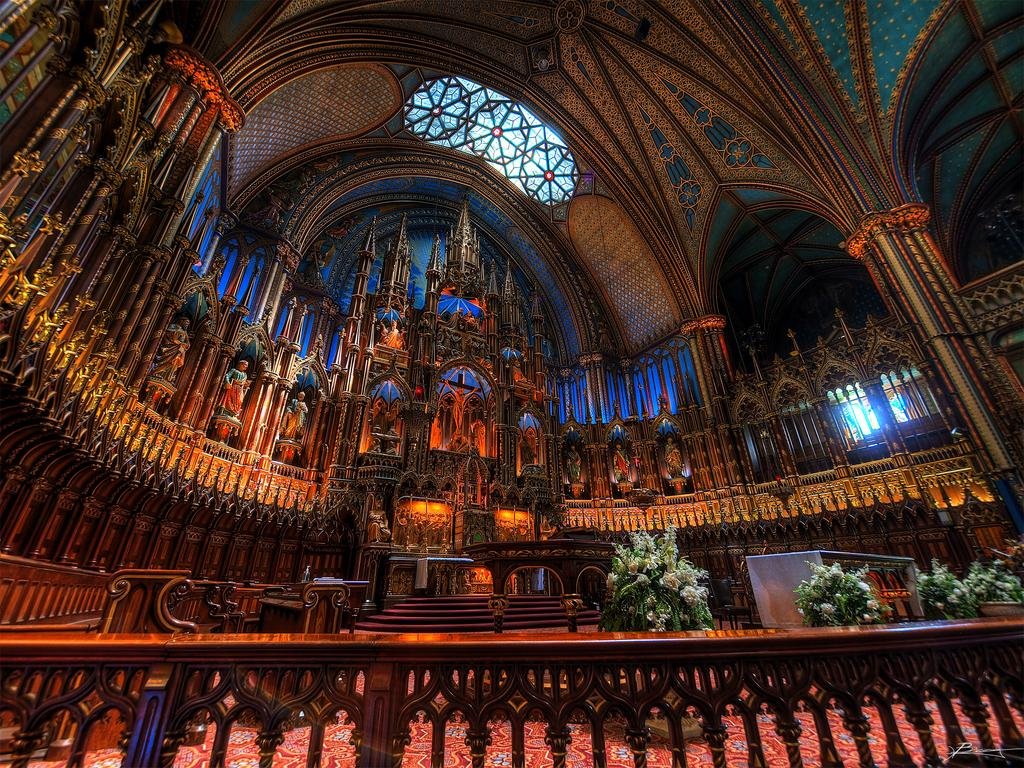What type of plants can be seen in the image? There are house plants in the image. What architectural feature is present in the image? There are stairs and a railing in the image. What can be seen at the top of the image? There is a window at the top of the image. What type of artwork is visible in the image? There are sculptures in the image. What is on the wall in the image? There is a design on the wall in the image. Where is the market located in the image? There is no market present in the image. What is the wish of the sculpture in the image? The sculpture in the image is an inanimate object and does not have wishes. 